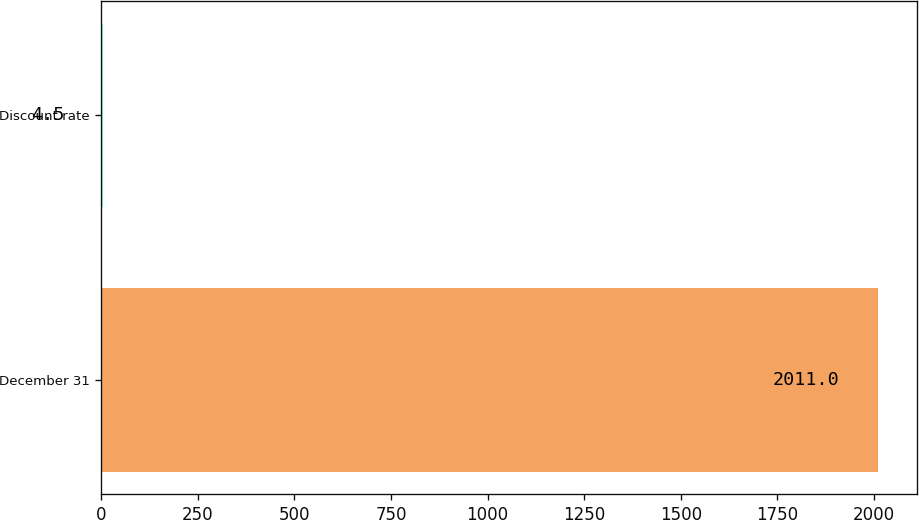Convert chart to OTSL. <chart><loc_0><loc_0><loc_500><loc_500><bar_chart><fcel>December 31<fcel>Discount rate<nl><fcel>2011<fcel>4.5<nl></chart> 